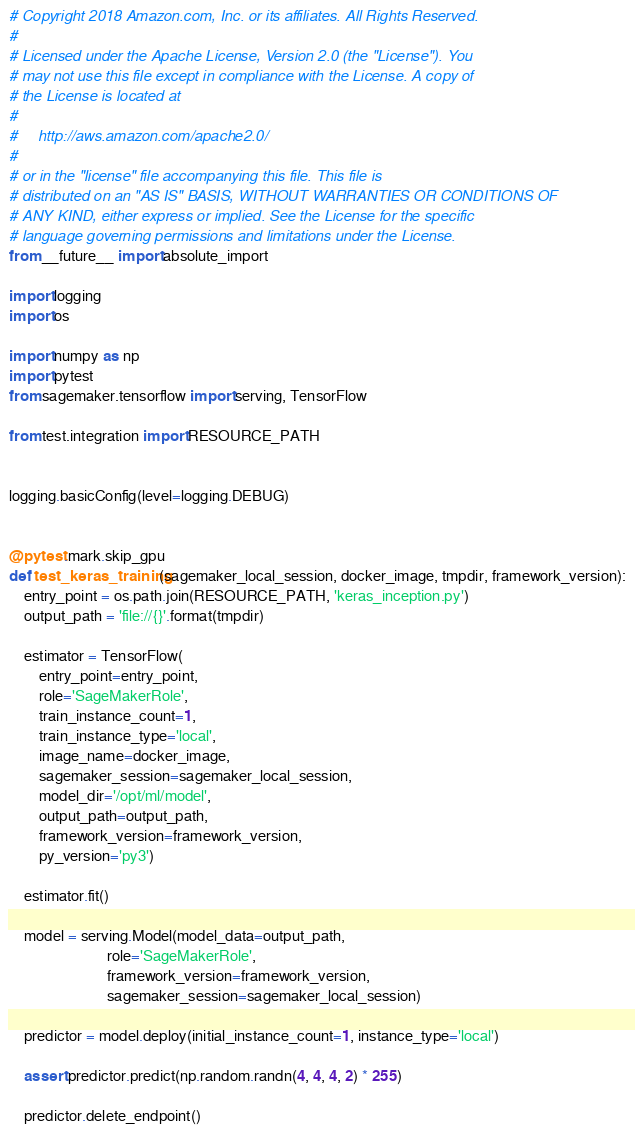Convert code to text. <code><loc_0><loc_0><loc_500><loc_500><_Python_># Copyright 2018 Amazon.com, Inc. or its affiliates. All Rights Reserved.
#
# Licensed under the Apache License, Version 2.0 (the "License"). You
# may not use this file except in compliance with the License. A copy of
# the License is located at
#
#     http://aws.amazon.com/apache2.0/
#
# or in the "license" file accompanying this file. This file is
# distributed on an "AS IS" BASIS, WITHOUT WARRANTIES OR CONDITIONS OF
# ANY KIND, either express or implied. See the License for the specific
# language governing permissions and limitations under the License.
from __future__ import absolute_import

import logging
import os

import numpy as np
import pytest
from sagemaker.tensorflow import serving, TensorFlow

from test.integration import RESOURCE_PATH


logging.basicConfig(level=logging.DEBUG)


@pytest.mark.skip_gpu
def test_keras_training(sagemaker_local_session, docker_image, tmpdir, framework_version):
    entry_point = os.path.join(RESOURCE_PATH, 'keras_inception.py')
    output_path = 'file://{}'.format(tmpdir)

    estimator = TensorFlow(
        entry_point=entry_point,
        role='SageMakerRole',
        train_instance_count=1,
        train_instance_type='local',
        image_name=docker_image,
        sagemaker_session=sagemaker_local_session,
        model_dir='/opt/ml/model',
        output_path=output_path,
        framework_version=framework_version,
        py_version='py3')

    estimator.fit()

    model = serving.Model(model_data=output_path,
                          role='SageMakerRole',
                          framework_version=framework_version,
                          sagemaker_session=sagemaker_local_session)

    predictor = model.deploy(initial_instance_count=1, instance_type='local')

    assert predictor.predict(np.random.randn(4, 4, 4, 2) * 255)

    predictor.delete_endpoint()
</code> 